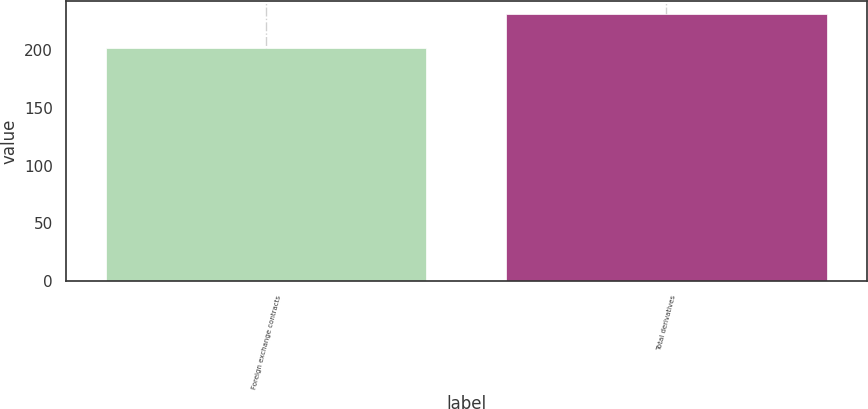Convert chart. <chart><loc_0><loc_0><loc_500><loc_500><bar_chart><fcel>Foreign exchange contracts<fcel>Total derivatives<nl><fcel>202<fcel>231<nl></chart> 